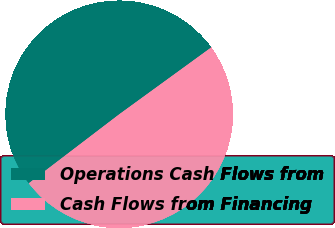Convert chart. <chart><loc_0><loc_0><loc_500><loc_500><pie_chart><fcel>Operations Cash Flows from<fcel>Cash Flows from Financing<nl><fcel>50.37%<fcel>49.63%<nl></chart> 